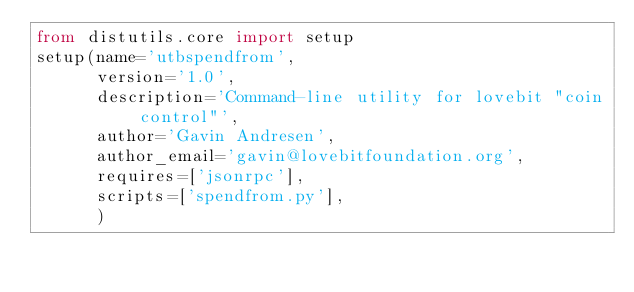<code> <loc_0><loc_0><loc_500><loc_500><_Python_>from distutils.core import setup
setup(name='utbspendfrom',
      version='1.0',
      description='Command-line utility for lovebit "coin control"',
      author='Gavin Andresen',
      author_email='gavin@lovebitfoundation.org',
      requires=['jsonrpc'],
      scripts=['spendfrom.py'],
      )
</code> 